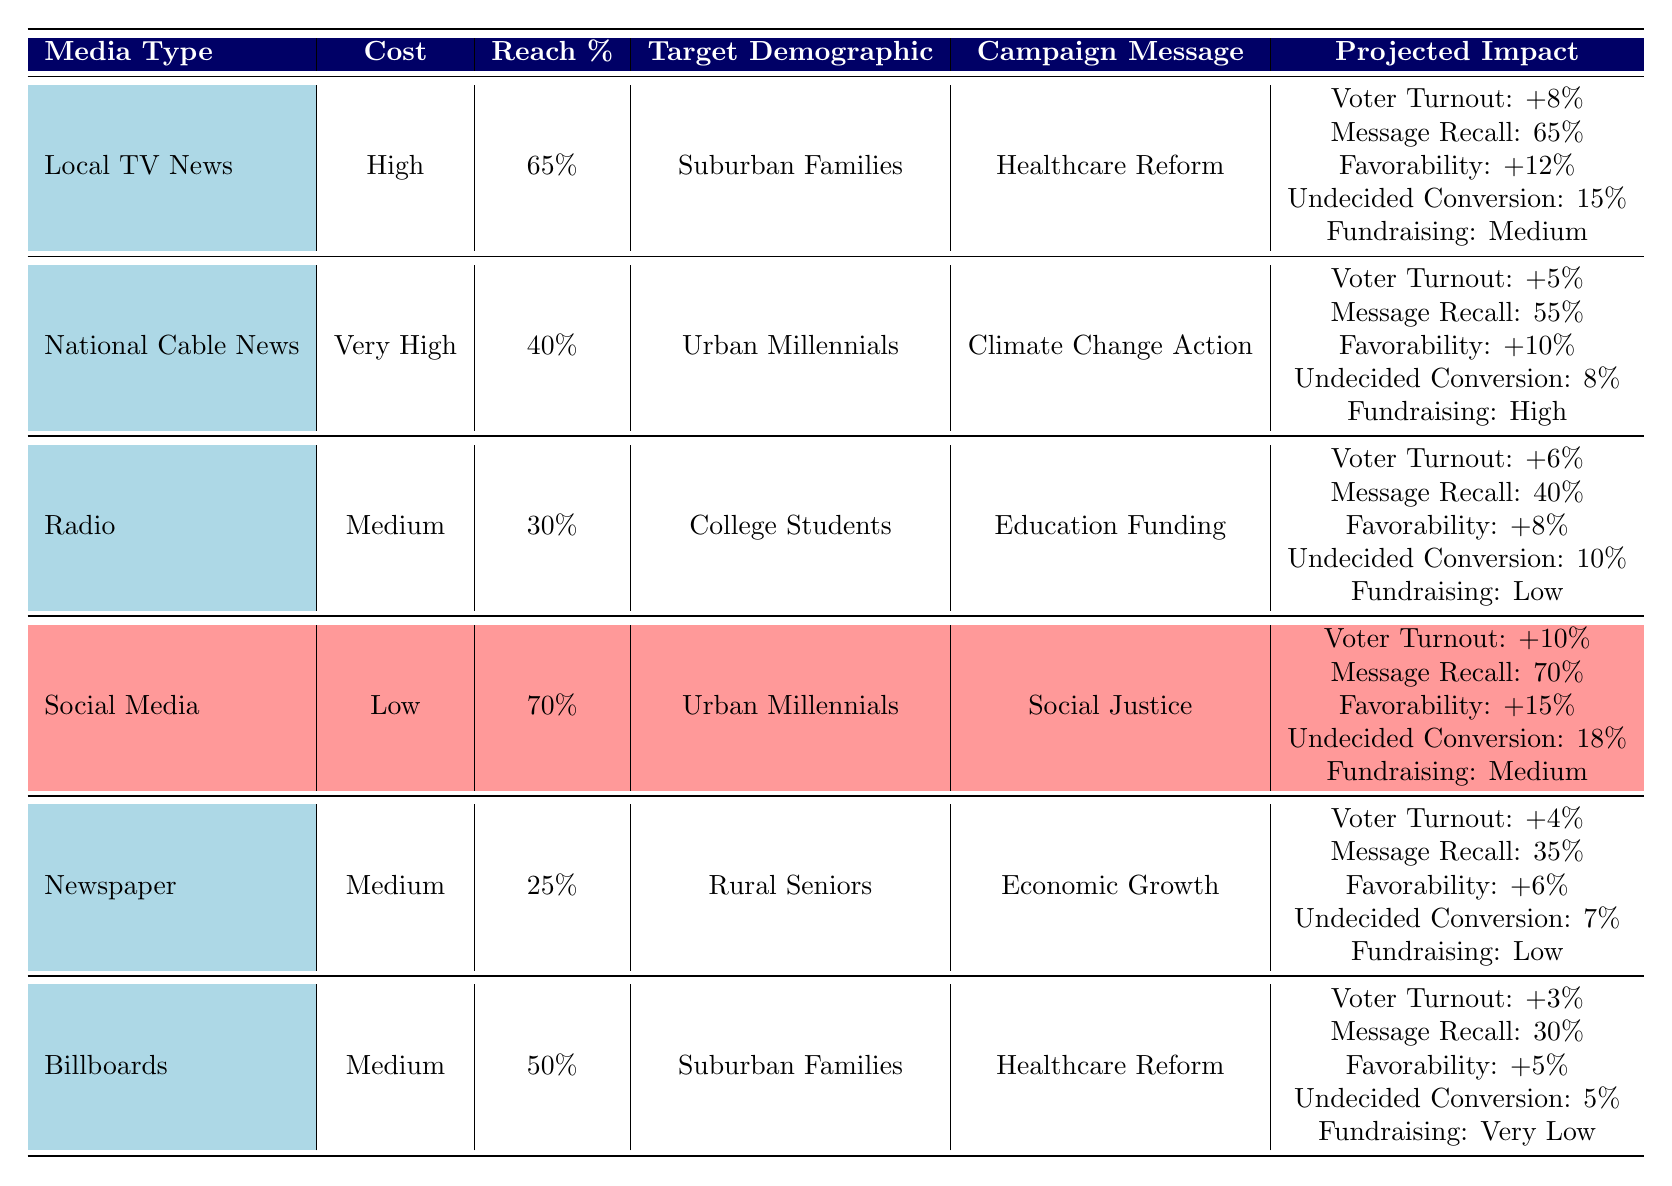What is the reach percentage of Social Media? The table indicates that Social Media has a reach percentage of 70%.
Answer: 70% Which media type has the highest projected voter turnout increase? Looking at the table, Social Media shows the highest projected voter turnout increase of +10%.
Answer: Social Media True or False: Radio has a higher message recall than the Newspaper. By comparing the table values, Radio has a message recall of 40% while the Newspaper has 35%. Therefore, the statement is true.
Answer: True What is the average voter turnout increase for the media types? The voter turnout increases for each media type are +8, +5, +6, +10, +4, and +3. Summing these gives: 8 + 5 + 6 + 10 + 4 + 3 = 36. There are 6 media types, so the average is 36 / 6 = 6.
Answer: 6 Which media type with a Low cost has the highest favorability boost? The only media type marked as Low cost is Social Media, which has a favorability boost of +15%. Thus, it also has the highest favorability boost among all media types as well.
Answer: Social Media 